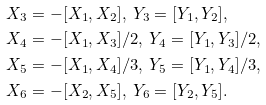Convert formula to latex. <formula><loc_0><loc_0><loc_500><loc_500>& X _ { 3 } = - [ X _ { 1 } , X _ { 2 } ] , \ Y _ { 3 } = [ Y _ { 1 } , Y _ { 2 } ] , \\ & X _ { 4 } = - [ X _ { 1 } , X _ { 3 } ] / 2 , \ Y _ { 4 } = [ Y _ { 1 } , Y _ { 3 } ] / 2 , \\ & X _ { 5 } = - [ X _ { 1 } , X _ { 4 } ] / 3 , \ Y _ { 5 } = [ Y _ { 1 } , Y _ { 4 } ] / 3 , \\ & X _ { 6 } = - [ X _ { 2 } , X _ { 5 } ] , \ Y _ { 6 } = [ Y _ { 2 } , Y _ { 5 } ] .</formula> 